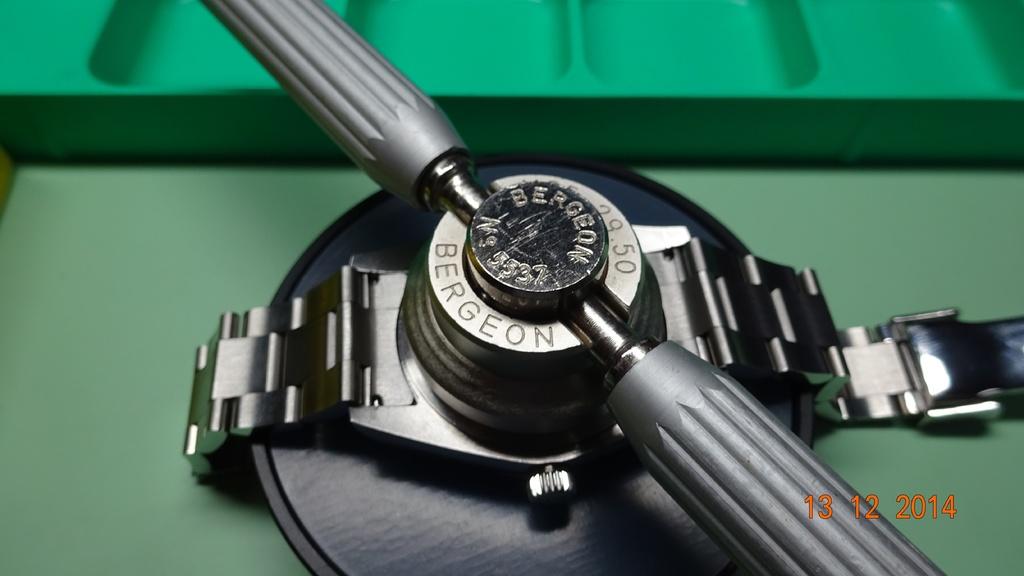When is this photo taken?
Provide a succinct answer. 13 12 2014. What is the company name of the device being used to hold the watch?
Your answer should be compact. Bergeon. 